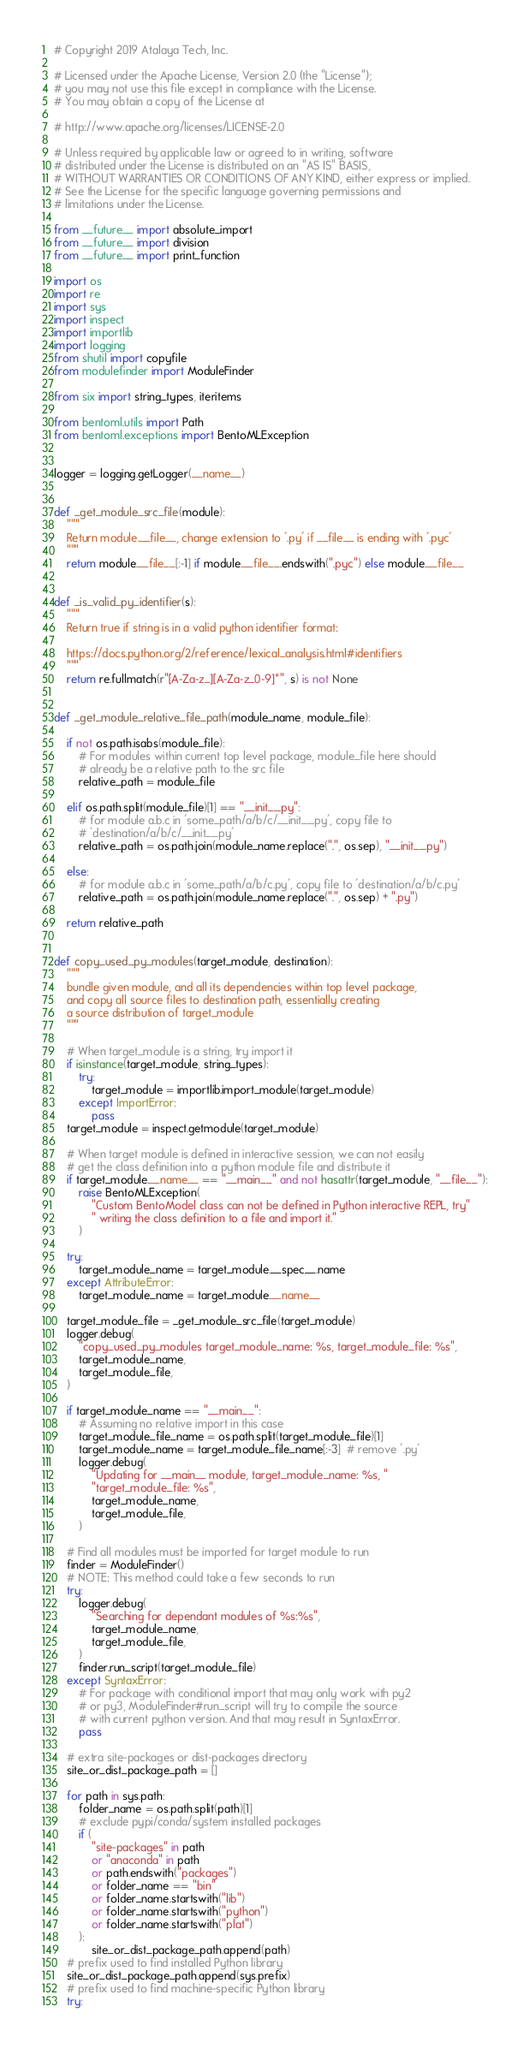<code> <loc_0><loc_0><loc_500><loc_500><_Python_># Copyright 2019 Atalaya Tech, Inc.

# Licensed under the Apache License, Version 2.0 (the "License");
# you may not use this file except in compliance with the License.
# You may obtain a copy of the License at

# http://www.apache.org/licenses/LICENSE-2.0

# Unless required by applicable law or agreed to in writing, software
# distributed under the License is distributed on an "AS IS" BASIS,
# WITHOUT WARRANTIES OR CONDITIONS OF ANY KIND, either express or implied.
# See the License for the specific language governing permissions and
# limitations under the License.

from __future__ import absolute_import
from __future__ import division
from __future__ import print_function

import os
import re
import sys
import inspect
import importlib
import logging
from shutil import copyfile
from modulefinder import ModuleFinder

from six import string_types, iteritems

from bentoml.utils import Path
from bentoml.exceptions import BentoMLException


logger = logging.getLogger(__name__)


def _get_module_src_file(module):
    """
    Return module.__file__, change extension to '.py' if __file__ is ending with '.pyc'
    """
    return module.__file__[:-1] if module.__file__.endswith(".pyc") else module.__file__


def _is_valid_py_identifier(s):
    """
    Return true if string is in a valid python identifier format:

    https://docs.python.org/2/reference/lexical_analysis.html#identifiers
    """
    return re.fullmatch(r"[A-Za-z_][A-Za-z_0-9]*", s) is not None


def _get_module_relative_file_path(module_name, module_file):

    if not os.path.isabs(module_file):
        # For modules within current top level package, module_file here should
        # already be a relative path to the src file
        relative_path = module_file

    elif os.path.split(module_file)[1] == "__init__.py":
        # for module a.b.c in 'some_path/a/b/c/__init__.py', copy file to
        # 'destination/a/b/c/__init__.py'
        relative_path = os.path.join(module_name.replace(".", os.sep), "__init__.py")

    else:
        # for module a.b.c in 'some_path/a/b/c.py', copy file to 'destination/a/b/c.py'
        relative_path = os.path.join(module_name.replace(".", os.sep) + ".py")

    return relative_path


def copy_used_py_modules(target_module, destination):
    """
    bundle given module, and all its dependencies within top level package,
    and copy all source files to destination path, essentially creating
    a source distribution of target_module
    """

    # When target_module is a string, try import it
    if isinstance(target_module, string_types):
        try:
            target_module = importlib.import_module(target_module)
        except ImportError:
            pass
    target_module = inspect.getmodule(target_module)

    # When target module is defined in interactive session, we can not easily
    # get the class definition into a python module file and distribute it
    if target_module.__name__ == "__main__" and not hasattr(target_module, "__file__"):
        raise BentoMLException(
            "Custom BentoModel class can not be defined in Python interactive REPL, try"
            " writing the class definition to a file and import it."
        )

    try:
        target_module_name = target_module.__spec__.name
    except AttributeError:
        target_module_name = target_module.__name__

    target_module_file = _get_module_src_file(target_module)
    logger.debug(
        "copy_used_py_modules target_module_name: %s, target_module_file: %s",
        target_module_name,
        target_module_file,
    )

    if target_module_name == "__main__":
        # Assuming no relative import in this case
        target_module_file_name = os.path.split(target_module_file)[1]
        target_module_name = target_module_file_name[:-3]  # remove '.py'
        logger.debug(
            "Updating for __main__ module, target_module_name: %s, "
            "target_module_file: %s",
            target_module_name,
            target_module_file,
        )

    # Find all modules must be imported for target module to run
    finder = ModuleFinder()
    # NOTE: This method could take a few seconds to run
    try:
        logger.debug(
            "Searching for dependant modules of %s:%s",
            target_module_name,
            target_module_file,
        )
        finder.run_script(target_module_file)
    except SyntaxError:
        # For package with conditional import that may only work with py2
        # or py3, ModuleFinder#run_script will try to compile the source
        # with current python version. And that may result in SyntaxError.
        pass

    # extra site-packages or dist-packages directory
    site_or_dist_package_path = []

    for path in sys.path:
        folder_name = os.path.split(path)[1]
        # exclude pypi/conda/system installed packages
        if (
            "site-packages" in path
            or "anaconda" in path
            or path.endswith("packages")
            or folder_name == "bin"
            or folder_name.startswith("lib")
            or folder_name.startswith("python")
            or folder_name.startswith("plat")
        ):
            site_or_dist_package_path.append(path)
    # prefix used to find installed Python library
    site_or_dist_package_path.append(sys.prefix)
    # prefix used to find machine-specific Python library
    try:</code> 